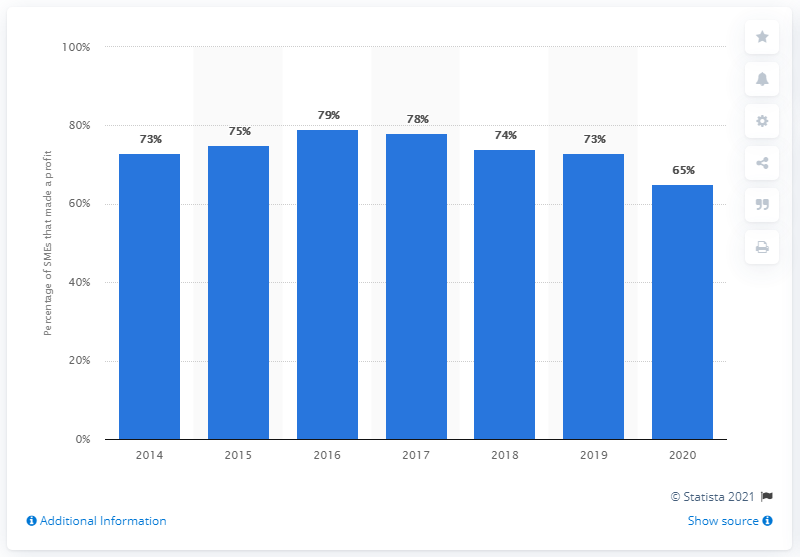Indicate a few pertinent items in this graphic. According to statistics, 79% of hospitality SMEs in the UK made a profit between 2014 and 2020. 